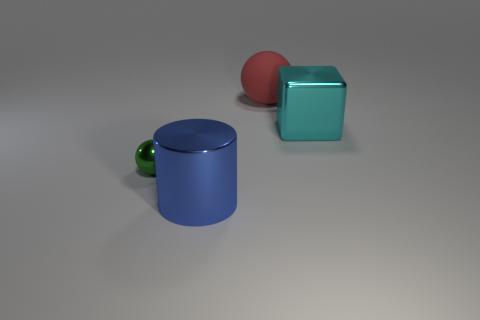Is the material of the object on the right side of the big ball the same as the tiny green thing?
Provide a succinct answer. Yes. What number of things are big shiny cubes or tiny yellow things?
Provide a succinct answer. 1. There is a green shiny object that is the same shape as the large red rubber thing; what size is it?
Offer a terse response. Small. What size is the cyan metal thing?
Your answer should be compact. Large. Are there more big red balls that are on the left side of the green shiny sphere than big blue things?
Offer a terse response. No. Is there any other thing that has the same material as the big cube?
Provide a succinct answer. Yes. Does the metallic thing that is in front of the tiny green ball have the same color as the shiny object that is behind the tiny shiny thing?
Ensure brevity in your answer.  No. What is the material of the ball that is in front of the shiny thing behind the thing to the left of the large metallic cylinder?
Keep it short and to the point. Metal. Is the number of cyan objects greater than the number of red shiny blocks?
Provide a short and direct response. Yes. Is there any other thing of the same color as the rubber sphere?
Give a very brief answer. No. 